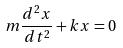<formula> <loc_0><loc_0><loc_500><loc_500>m \frac { d ^ { 2 } x } { d t ^ { 2 } } + k x = 0</formula> 